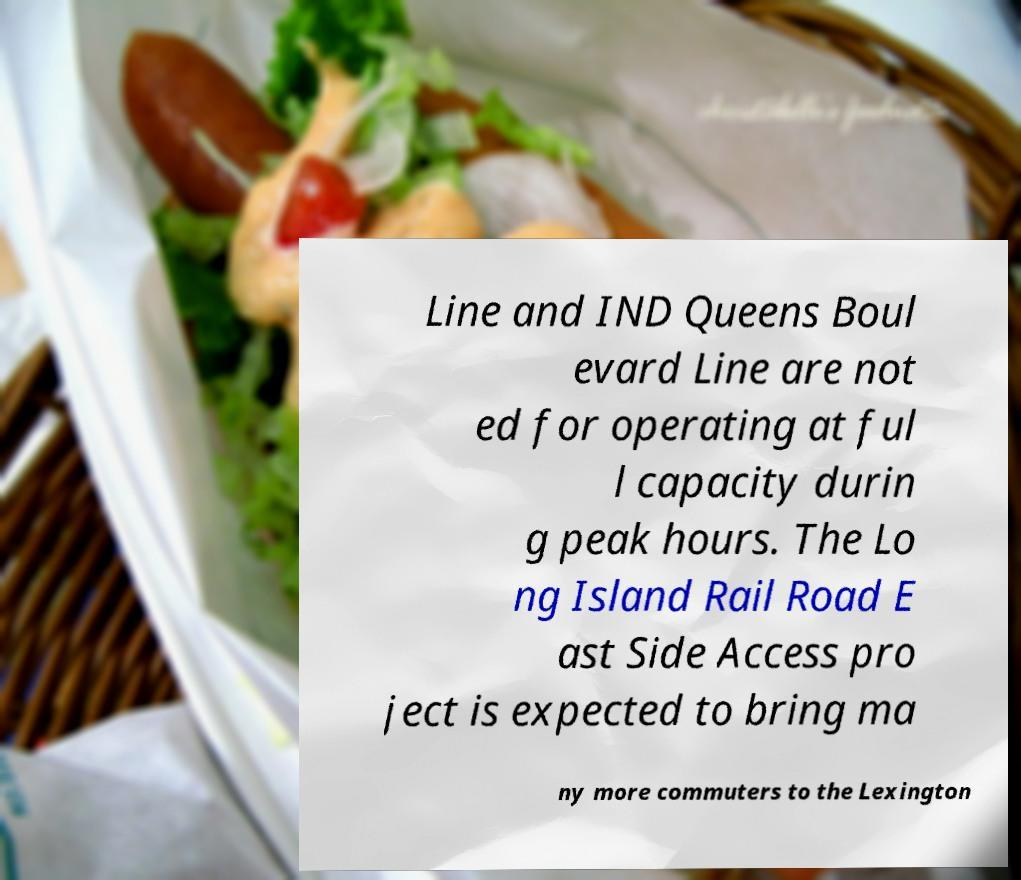Could you assist in decoding the text presented in this image and type it out clearly? Line and IND Queens Boul evard Line are not ed for operating at ful l capacity durin g peak hours. The Lo ng Island Rail Road E ast Side Access pro ject is expected to bring ma ny more commuters to the Lexington 